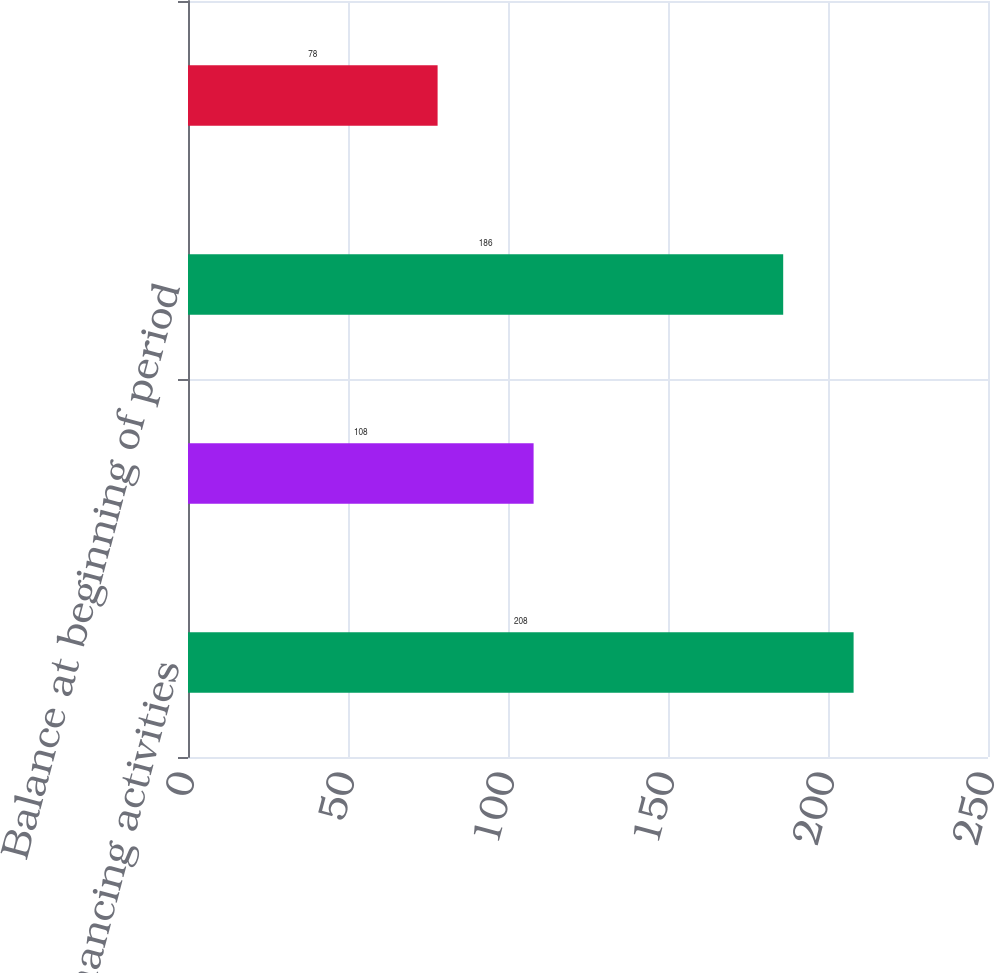<chart> <loc_0><loc_0><loc_500><loc_500><bar_chart><fcel>Financing activities<fcel>Net change<fcel>Balance at beginning of period<fcel>Balance at end of period<nl><fcel>208<fcel>108<fcel>186<fcel>78<nl></chart> 